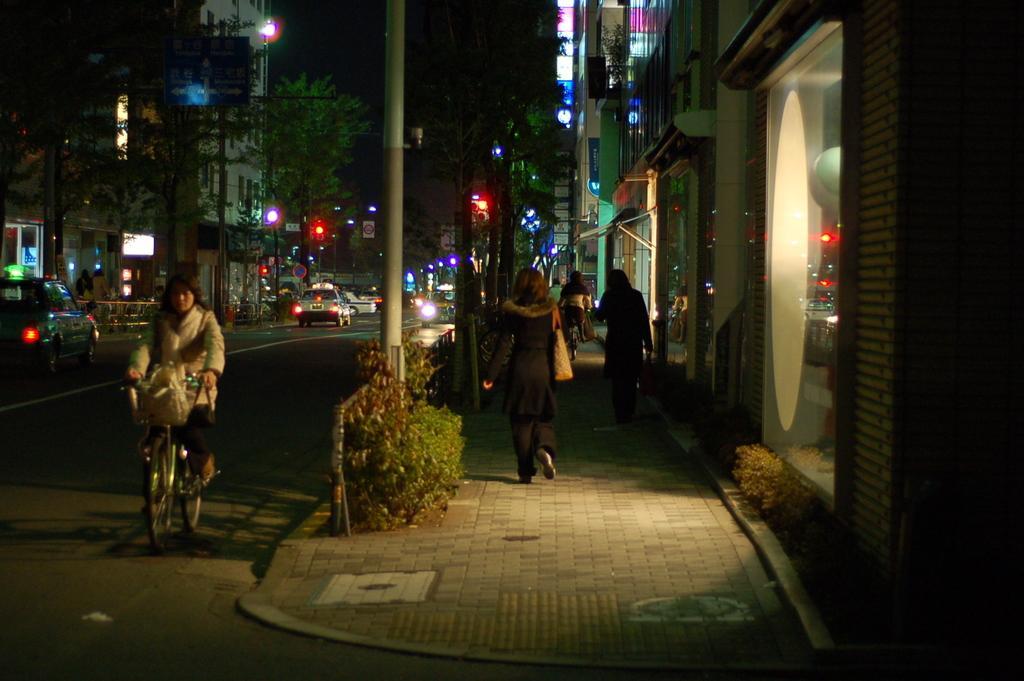How would you summarize this image in a sentence or two? There are two women's walking in a street view and there is another women riding bicycle beside them and there are cars,trees and buildings in the background. 